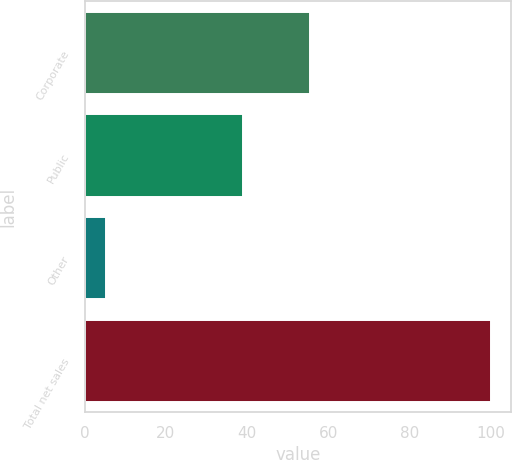Convert chart to OTSL. <chart><loc_0><loc_0><loc_500><loc_500><bar_chart><fcel>Corporate<fcel>Public<fcel>Other<fcel>Total net sales<nl><fcel>55.6<fcel>39.1<fcel>5.3<fcel>100<nl></chart> 